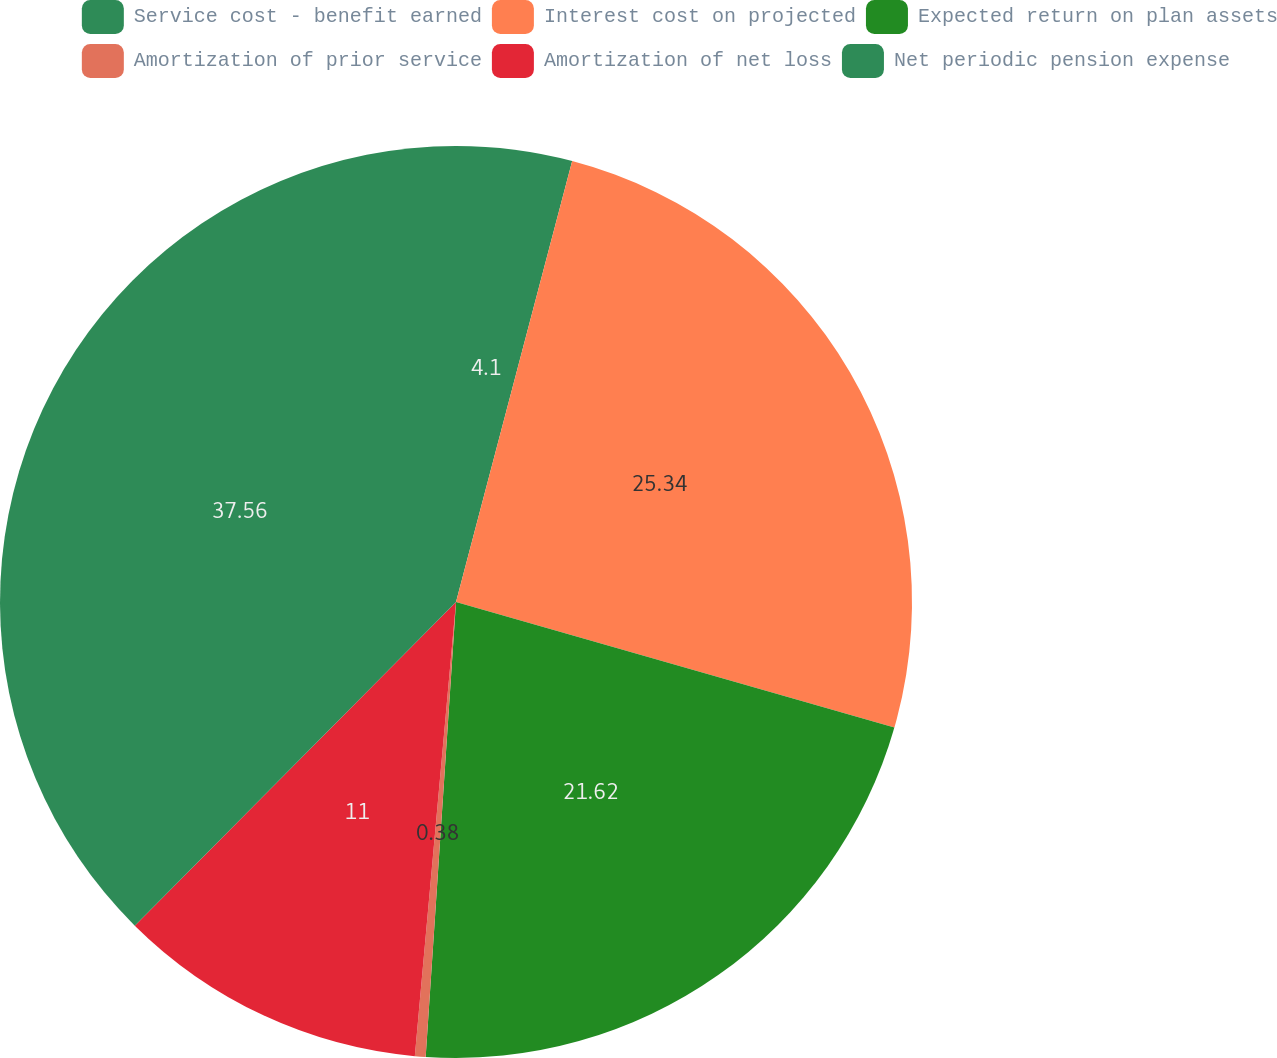<chart> <loc_0><loc_0><loc_500><loc_500><pie_chart><fcel>Service cost - benefit earned<fcel>Interest cost on projected<fcel>Expected return on plan assets<fcel>Amortization of prior service<fcel>Amortization of net loss<fcel>Net periodic pension expense<nl><fcel>4.1%<fcel>25.34%<fcel>21.62%<fcel>0.38%<fcel>11.0%<fcel>37.56%<nl></chart> 